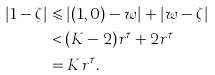<formula> <loc_0><loc_0><loc_500><loc_500>| 1 - \zeta | & \leqslant \left | ( 1 , 0 ) - w \right | + | w - \zeta | \\ & < ( K - 2 ) r ^ { \tau } + 2 r ^ { \tau } \\ & = K r ^ { \tau } .</formula> 